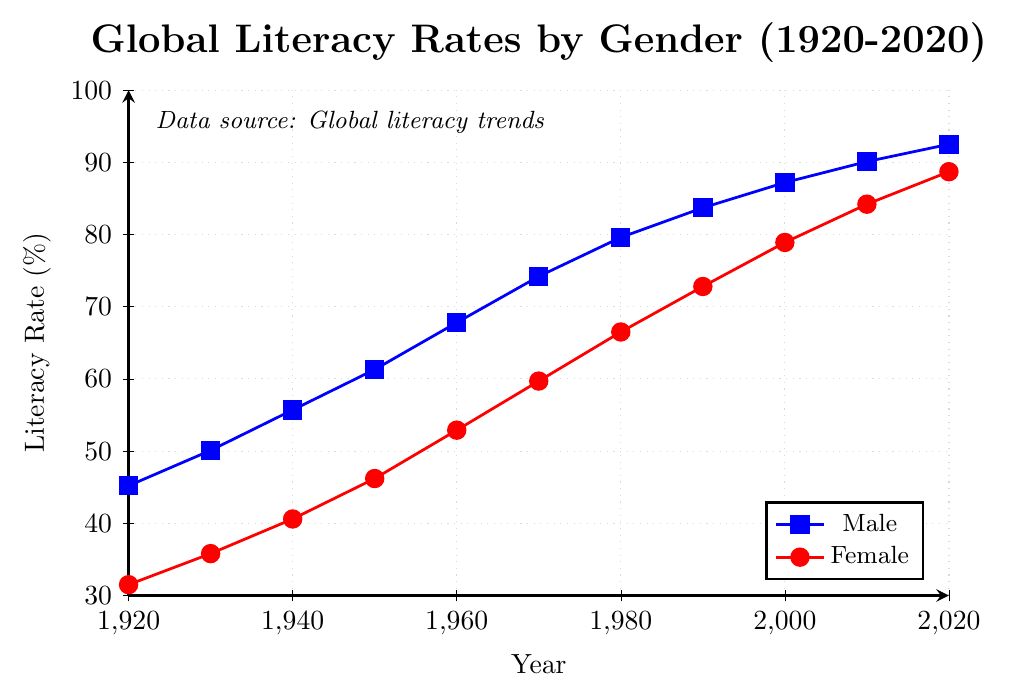what are the average literacy rates of males and females in 1980? To find the average literacy rates of males and females in 1980, locate the data points on the figure: 79.6% for males and 66.5% for females. No calculations are needed.
Answer: 79.6%, 66.5% what's the difference in literacy rates between males and females in 1930? First, identify the literacy rates in 1930: 50.1% for males and 35.8% for females. Then subtract the female rate from the male rate: 50.1 - 35.8 = 14.3%.
Answer: 14.3% how did the literacy rates for males change from 1940 to 1950? Locate the male literacy rates for the years 1940 and 1950: 55.7% and 61.3%, respectively. Calculate the change by subtracting the 1940 rate from the 1950 rate: 61.3 - 55.7 = 5.6%.
Answer: increased by 5.6% Between which two decades did women experience the greatest increase in literacy rate? Compare the differences between female literacy rates in each decade by subtracting earlier values from later values: between 1920 and 1930 (35.8 - 31.5 = 4.3%), 1930 and 1940 (40.6 - 35.8 = 4.8%), 1940 and 1950 (46.2 - 40.6 = 5.6%), 1950 and 1960 (52.9 - 46.2 = 6.7%), 1960 and 1970 (59.7 - 52.9 = 6.8%), 1970 and 1980 (66.5 - 59.7 = 6.8%), 1980 and 1990 (72.8 - 66.5 = 6.3%), 1990 and 2000 (78.9 - 72.8 = 6.1%), 2000 and 2010 (84.2 - 78.9 = 5.3%), and 2010 and 2020 (88.7 - 84.2 = 4.5%). The greatest increase was between 1960-1970 and 1970-1980, both showing 6.8%.
Answer: 1960-1970 and 1970-1980 what is the trend in the literacy rate gap between genders from 1920 to 2020? Note the literacy rates for males and females across the years and calculate the differences: 1920: 45.2 - 31.5 = 13.7%, 1930: 50.1 - 35.8 = 14.3%, 1940: 55.7 - 40.6 = 15.1%, 1950: 61.3 - 46.2 = 15.1%, 1960: 67.8 - 52.9 = 14.9%, 1970: 74.2 - 59.7 = 14.5%, 1980: 79.6 - 66.5 = 13.1%, 1990: 83.7 - 72.8 = 10.9%, 2000: 87.2 - 78.9 = 8.3%, 2010: 90.1 - 84.2 = 5.9%, 2020: 92.5 - 88.7 = 3.8%. The gap has been narrowing over time.
Answer: decreasing 